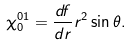Convert formula to latex. <formula><loc_0><loc_0><loc_500><loc_500>\chi _ { 0 } ^ { 0 1 } = \frac { d f } { d r } r ^ { 2 } \sin \theta .</formula> 